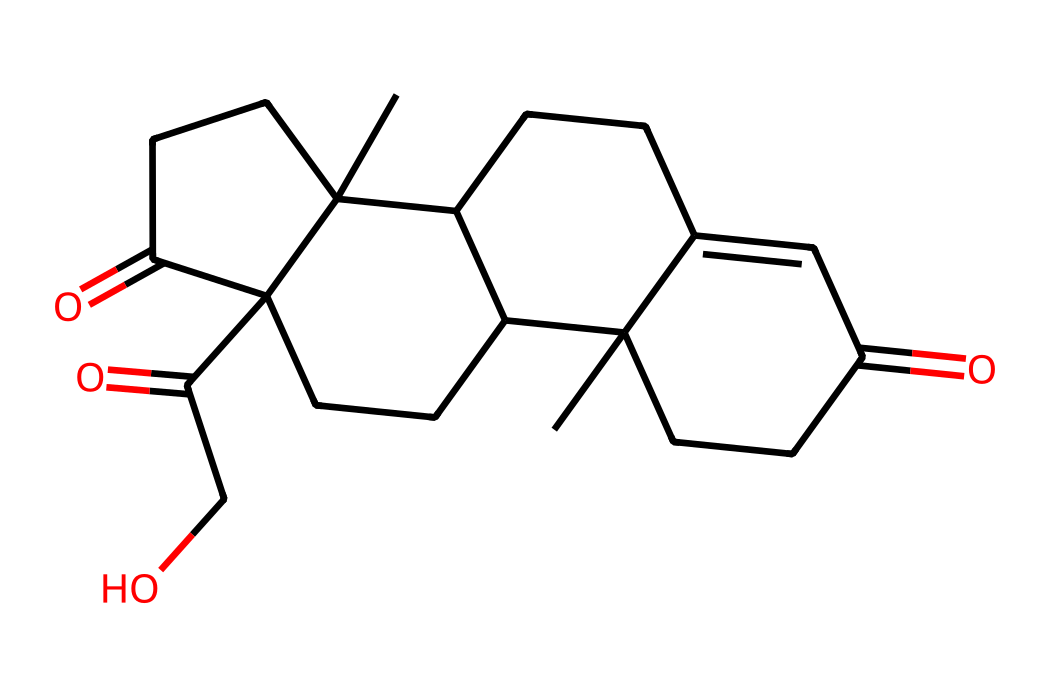what is the main functional group present in cortisone? The chemical structure includes a carbonyl group (C=O), which is characteristic of ketones. This can be identified by locating the C=O bonds in the molecular structure.
Answer: ketone how many carbon atoms are in cortisone? By analyzing the structure, count the carbon atoms present in the ring and chain portions of the molecule. There are a total of 21 carbon atoms.
Answer: 21 how many double bonds are present in the cortisone structure? The visual examination of the chemical structure reveals two C=C double bonds. They are identified by the double bond notation between carbon atoms.
Answer: 2 what type of reaction can cortisone undergo due to its carbonyl groups? Carbonyl groups can undergo nucleophilic addition reactions, particularly reactions with alcohols. This is due to the electrophilic nature of the carbonyl carbon.
Answer: nucleophilic addition which type of isomerism might be relevant for cortisone considering its structure? The presence of multiple chiral centers in cortisone suggests that stereoisomerism is relevant. This is due to its structure containing asymmetric centers that can exist in different configurations.
Answer: stereoisomerism what is the molecular formula of cortisone derived from its structure? To derive the molecular formula from the structure, one counts the various atoms (C, H, O) present: 21 carbons, 28 hydrogens, and 5 oxygens result in the formula C21H28O5.
Answer: C21H28O5 